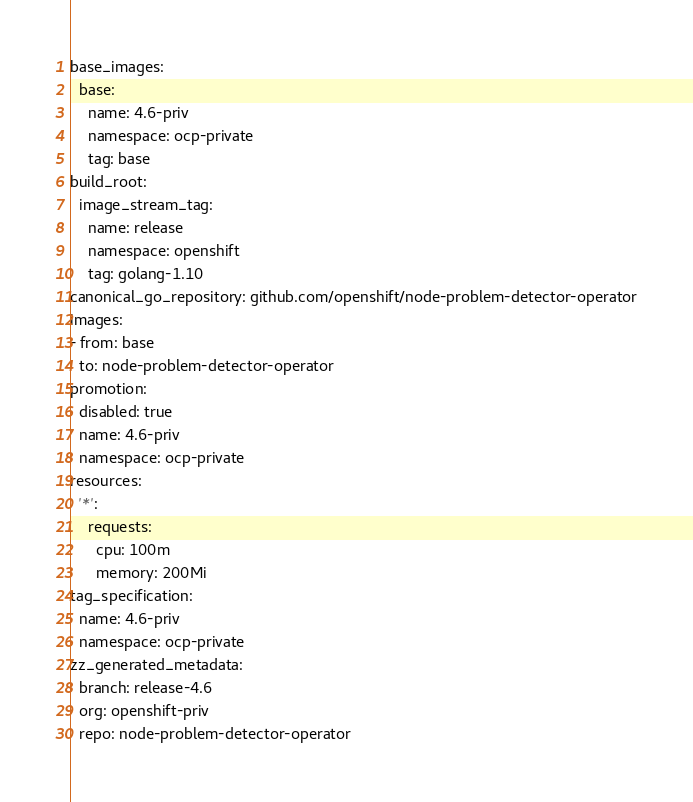Convert code to text. <code><loc_0><loc_0><loc_500><loc_500><_YAML_>base_images:
  base:
    name: 4.6-priv
    namespace: ocp-private
    tag: base
build_root:
  image_stream_tag:
    name: release
    namespace: openshift
    tag: golang-1.10
canonical_go_repository: github.com/openshift/node-problem-detector-operator
images:
- from: base
  to: node-problem-detector-operator
promotion:
  disabled: true
  name: 4.6-priv
  namespace: ocp-private
resources:
  '*':
    requests:
      cpu: 100m
      memory: 200Mi
tag_specification:
  name: 4.6-priv
  namespace: ocp-private
zz_generated_metadata:
  branch: release-4.6
  org: openshift-priv
  repo: node-problem-detector-operator
</code> 